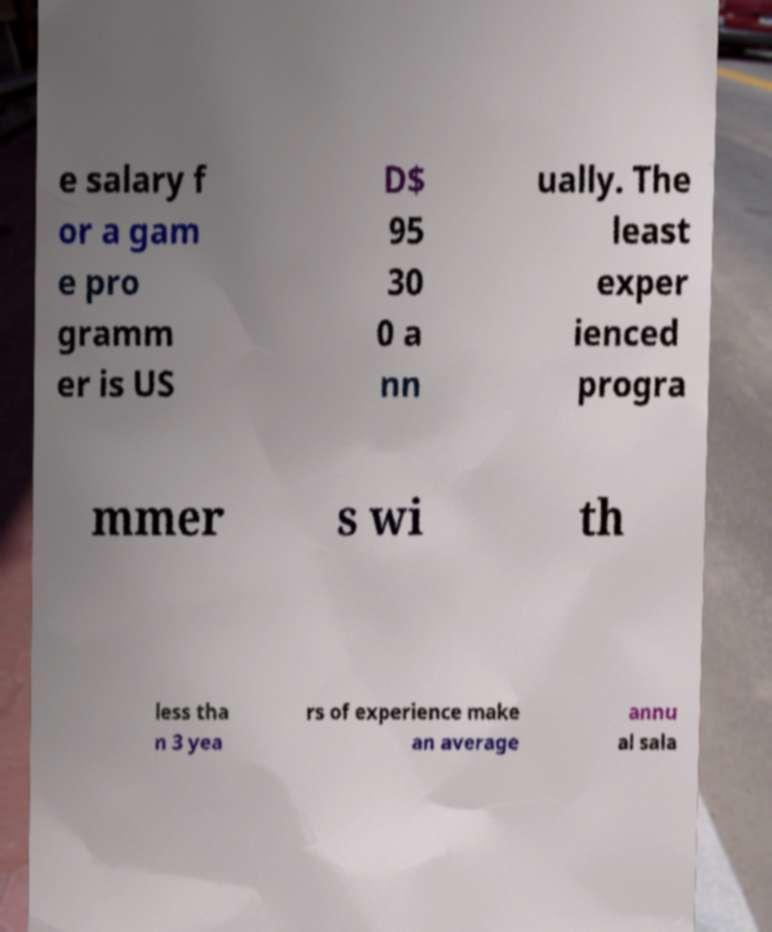Can you accurately transcribe the text from the provided image for me? e salary f or a gam e pro gramm er is US D$ 95 30 0 a nn ually. The least exper ienced progra mmer s wi th less tha n 3 yea rs of experience make an average annu al sala 